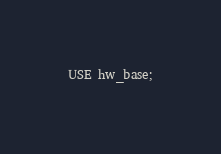<code> <loc_0><loc_0><loc_500><loc_500><_SQL_>USE hw_base;

</code> 